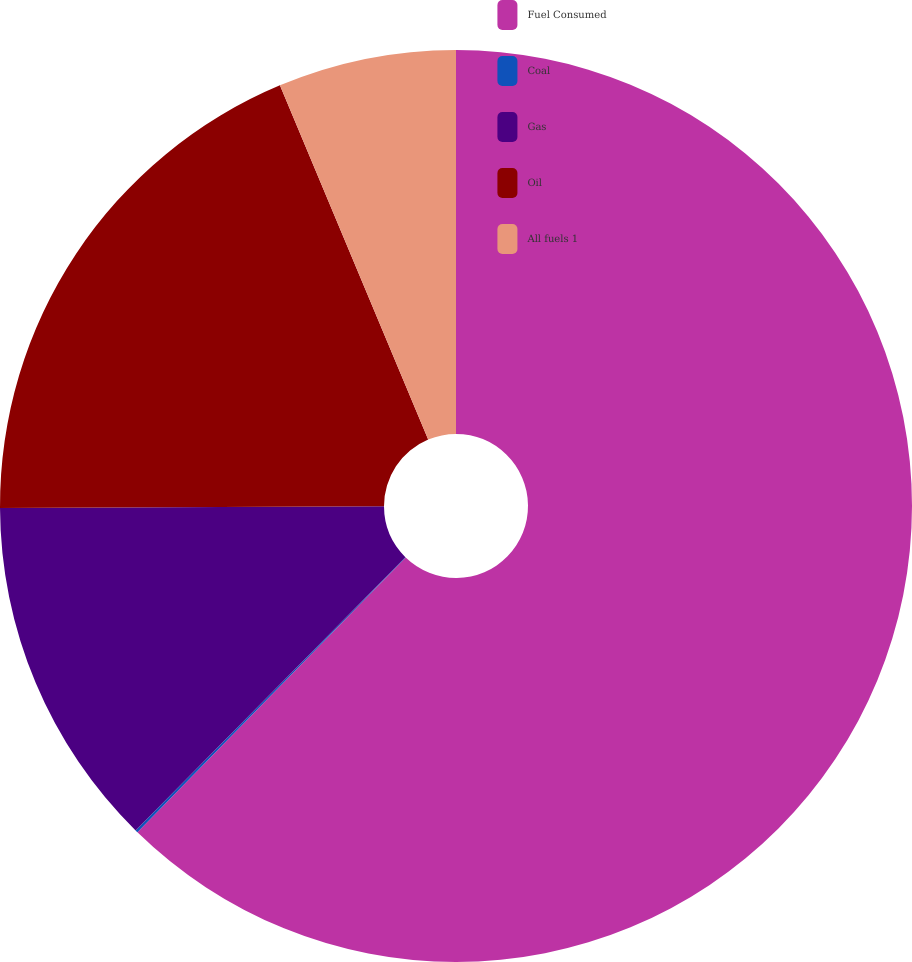<chart> <loc_0><loc_0><loc_500><loc_500><pie_chart><fcel>Fuel Consumed<fcel>Coal<fcel>Gas<fcel>Oil<fcel>All fuels 1<nl><fcel>62.31%<fcel>0.09%<fcel>12.53%<fcel>18.76%<fcel>6.31%<nl></chart> 